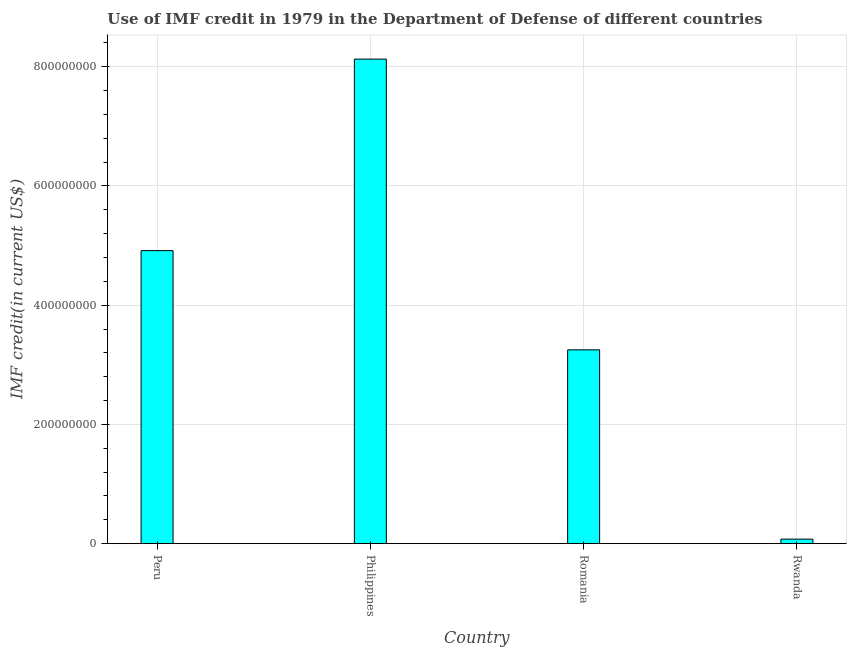Does the graph contain any zero values?
Ensure brevity in your answer.  No. Does the graph contain grids?
Your response must be concise. Yes. What is the title of the graph?
Ensure brevity in your answer.  Use of IMF credit in 1979 in the Department of Defense of different countries. What is the label or title of the Y-axis?
Make the answer very short. IMF credit(in current US$). What is the use of imf credit in dod in Philippines?
Offer a very short reply. 8.13e+08. Across all countries, what is the maximum use of imf credit in dod?
Keep it short and to the point. 8.13e+08. Across all countries, what is the minimum use of imf credit in dod?
Provide a succinct answer. 7.58e+06. In which country was the use of imf credit in dod minimum?
Make the answer very short. Rwanda. What is the sum of the use of imf credit in dod?
Provide a short and direct response. 1.64e+09. What is the difference between the use of imf credit in dod in Peru and Romania?
Give a very brief answer. 1.66e+08. What is the average use of imf credit in dod per country?
Keep it short and to the point. 4.09e+08. What is the median use of imf credit in dod?
Ensure brevity in your answer.  4.08e+08. What is the ratio of the use of imf credit in dod in Philippines to that in Romania?
Ensure brevity in your answer.  2.5. Is the use of imf credit in dod in Peru less than that in Rwanda?
Offer a terse response. No. Is the difference between the use of imf credit in dod in Peru and Rwanda greater than the difference between any two countries?
Keep it short and to the point. No. What is the difference between the highest and the second highest use of imf credit in dod?
Your response must be concise. 3.21e+08. What is the difference between the highest and the lowest use of imf credit in dod?
Your response must be concise. 8.05e+08. Are all the bars in the graph horizontal?
Offer a very short reply. No. How many countries are there in the graph?
Your answer should be compact. 4. Are the values on the major ticks of Y-axis written in scientific E-notation?
Your answer should be very brief. No. What is the IMF credit(in current US$) of Peru?
Your answer should be compact. 4.92e+08. What is the IMF credit(in current US$) of Philippines?
Offer a very short reply. 8.13e+08. What is the IMF credit(in current US$) in Romania?
Provide a succinct answer. 3.25e+08. What is the IMF credit(in current US$) in Rwanda?
Your answer should be compact. 7.58e+06. What is the difference between the IMF credit(in current US$) in Peru and Philippines?
Offer a terse response. -3.21e+08. What is the difference between the IMF credit(in current US$) in Peru and Romania?
Offer a very short reply. 1.66e+08. What is the difference between the IMF credit(in current US$) in Peru and Rwanda?
Provide a succinct answer. 4.84e+08. What is the difference between the IMF credit(in current US$) in Philippines and Romania?
Make the answer very short. 4.88e+08. What is the difference between the IMF credit(in current US$) in Philippines and Rwanda?
Keep it short and to the point. 8.05e+08. What is the difference between the IMF credit(in current US$) in Romania and Rwanda?
Ensure brevity in your answer.  3.18e+08. What is the ratio of the IMF credit(in current US$) in Peru to that in Philippines?
Offer a very short reply. 0.6. What is the ratio of the IMF credit(in current US$) in Peru to that in Romania?
Ensure brevity in your answer.  1.51. What is the ratio of the IMF credit(in current US$) in Peru to that in Rwanda?
Keep it short and to the point. 64.81. What is the ratio of the IMF credit(in current US$) in Philippines to that in Romania?
Provide a short and direct response. 2.5. What is the ratio of the IMF credit(in current US$) in Philippines to that in Rwanda?
Make the answer very short. 107.18. What is the ratio of the IMF credit(in current US$) in Romania to that in Rwanda?
Keep it short and to the point. 42.87. 